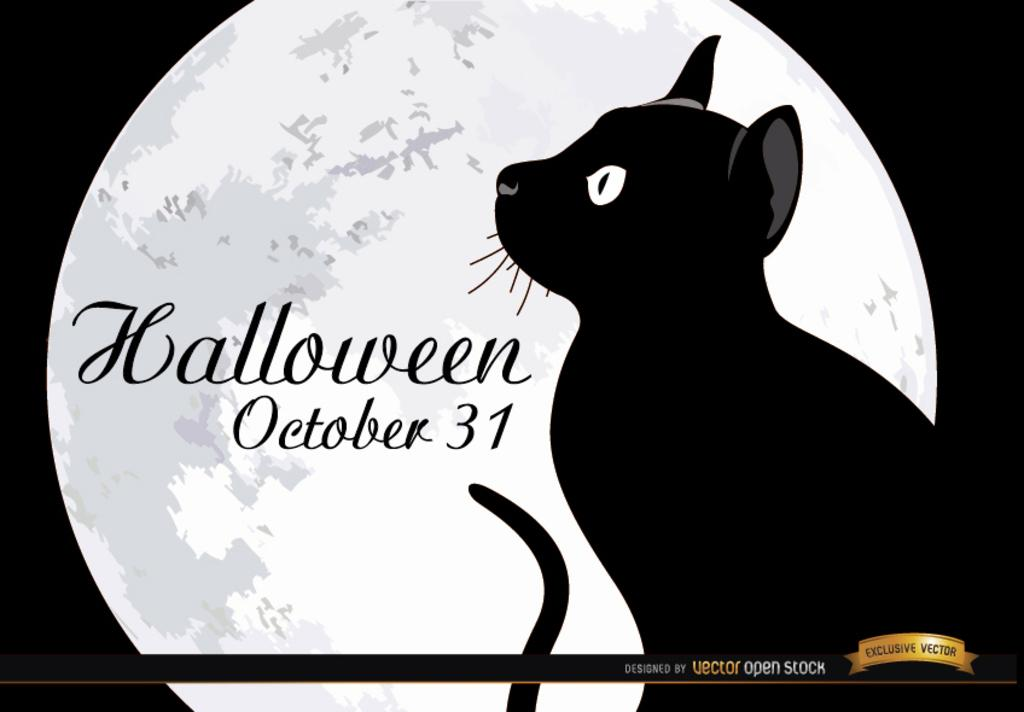What can be found in the image that contains written information? There is text in the image. What type of animal is present in the image? There is a cat in the image. What celestial body is visible in the image? The moon is visible in the image. Where can a watermark be found in the image? There is a watermark in the bottom right corner of the image. What type of berry is the cat eating in the image? There is no berry present in the image, and the cat is not eating anything. Can you describe the beetle that is crawling on the moon in the image? There is no beetle present in the image, and the moon is not depicted as having any living creatures on it. 